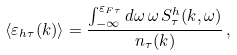<formula> <loc_0><loc_0><loc_500><loc_500>\langle \varepsilon _ { h \tau } ( k ) \rangle = \frac { \int _ { - \infty } ^ { \varepsilon _ { F \tau } } d \omega \, \omega \, S ^ { h } _ { \tau } ( k , \omega ) } { n _ { \tau } ( k ) } \, ,</formula> 